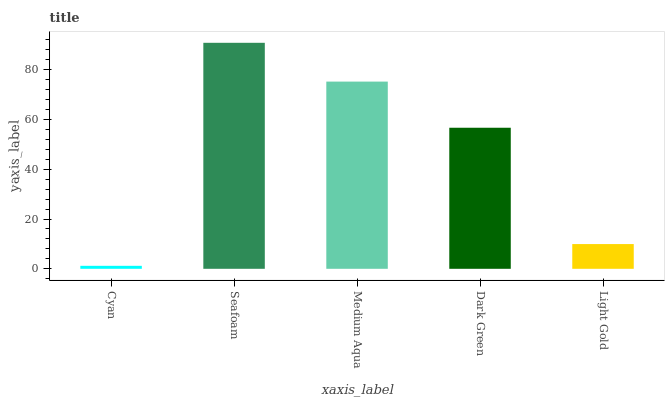Is Cyan the minimum?
Answer yes or no. Yes. Is Seafoam the maximum?
Answer yes or no. Yes. Is Medium Aqua the minimum?
Answer yes or no. No. Is Medium Aqua the maximum?
Answer yes or no. No. Is Seafoam greater than Medium Aqua?
Answer yes or no. Yes. Is Medium Aqua less than Seafoam?
Answer yes or no. Yes. Is Medium Aqua greater than Seafoam?
Answer yes or no. No. Is Seafoam less than Medium Aqua?
Answer yes or no. No. Is Dark Green the high median?
Answer yes or no. Yes. Is Dark Green the low median?
Answer yes or no. Yes. Is Medium Aqua the high median?
Answer yes or no. No. Is Cyan the low median?
Answer yes or no. No. 